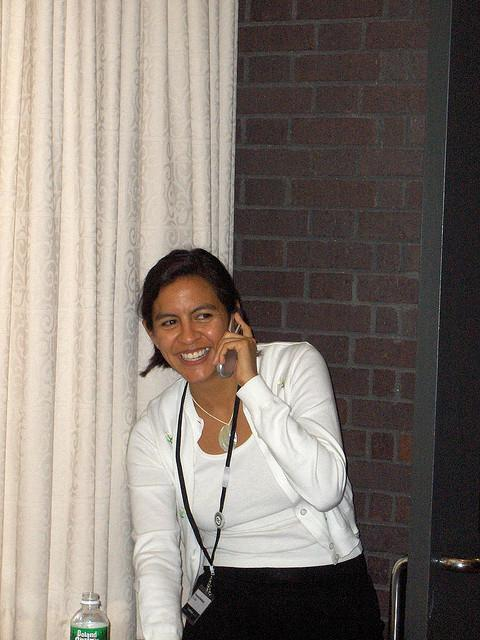How is she communicating?

Choices:
A) shouting
B) telegraph
C) computer
D) phone phone 